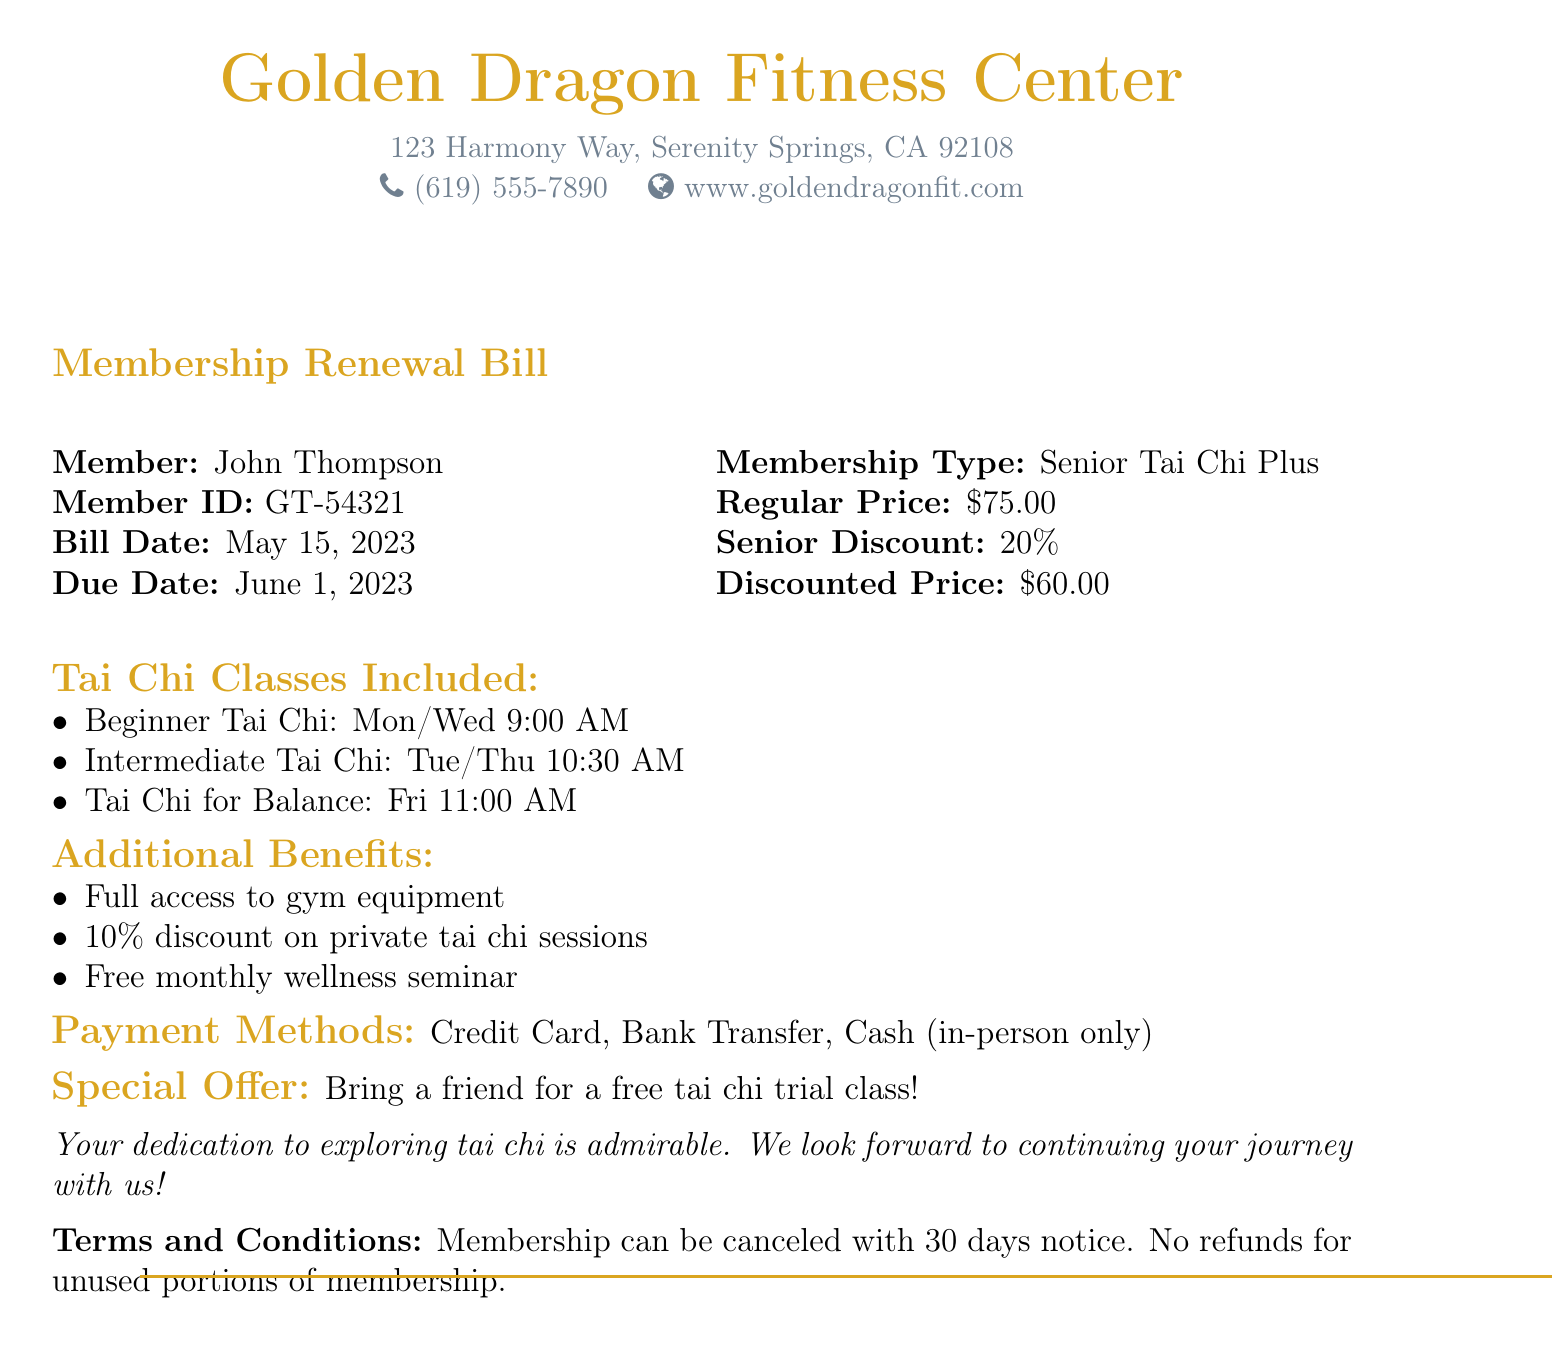What is the member's name? The member's name is found in the document under the "Member" section.
Answer: John Thompson What is the membership type? The membership type is listed under the "Membership Type" section of the bill.
Answer: Senior Tai Chi Plus What is the due date for the bill? The due date is specified in the document under "Due Date".
Answer: June 1, 2023 What is the regular price of the membership? The regular price can be found in the "Membership Type" section.
Answer: $75.00 What discount percentage is applied? The discount percentage is mentioned in the "Senior Discount" section of the document.
Answer: 20% What is the discounted price? The discounted price is listed under the "Membership Type" section.
Answer: $60.00 How many tai chi classes are included in the membership? The number of tai chi classes is derived from the list under "Tai Chi Classes Included".
Answer: Three What are the payment methods accepted? Payment methods are mentioned at the end of the document under "Payment Methods".
Answer: Credit Card, Bank Transfer, Cash (in-person only) What special offer is mentioned? The special offer can be found in the "Special Offer" section of the bill.
Answer: Bring a friend for a free tai chi trial class! 